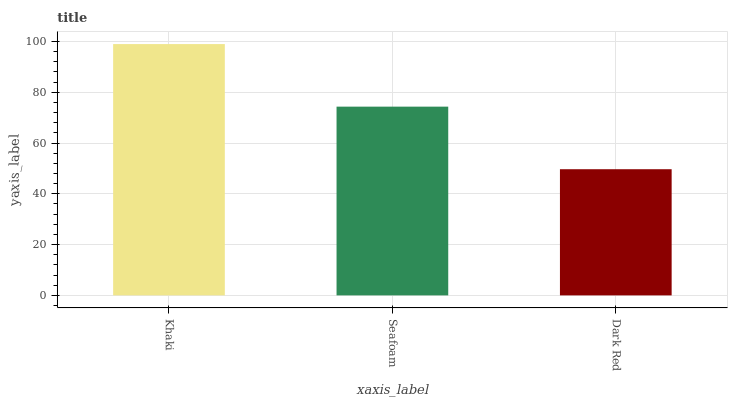Is Dark Red the minimum?
Answer yes or no. Yes. Is Khaki the maximum?
Answer yes or no. Yes. Is Seafoam the minimum?
Answer yes or no. No. Is Seafoam the maximum?
Answer yes or no. No. Is Khaki greater than Seafoam?
Answer yes or no. Yes. Is Seafoam less than Khaki?
Answer yes or no. Yes. Is Seafoam greater than Khaki?
Answer yes or no. No. Is Khaki less than Seafoam?
Answer yes or no. No. Is Seafoam the high median?
Answer yes or no. Yes. Is Seafoam the low median?
Answer yes or no. Yes. Is Dark Red the high median?
Answer yes or no. No. Is Khaki the low median?
Answer yes or no. No. 